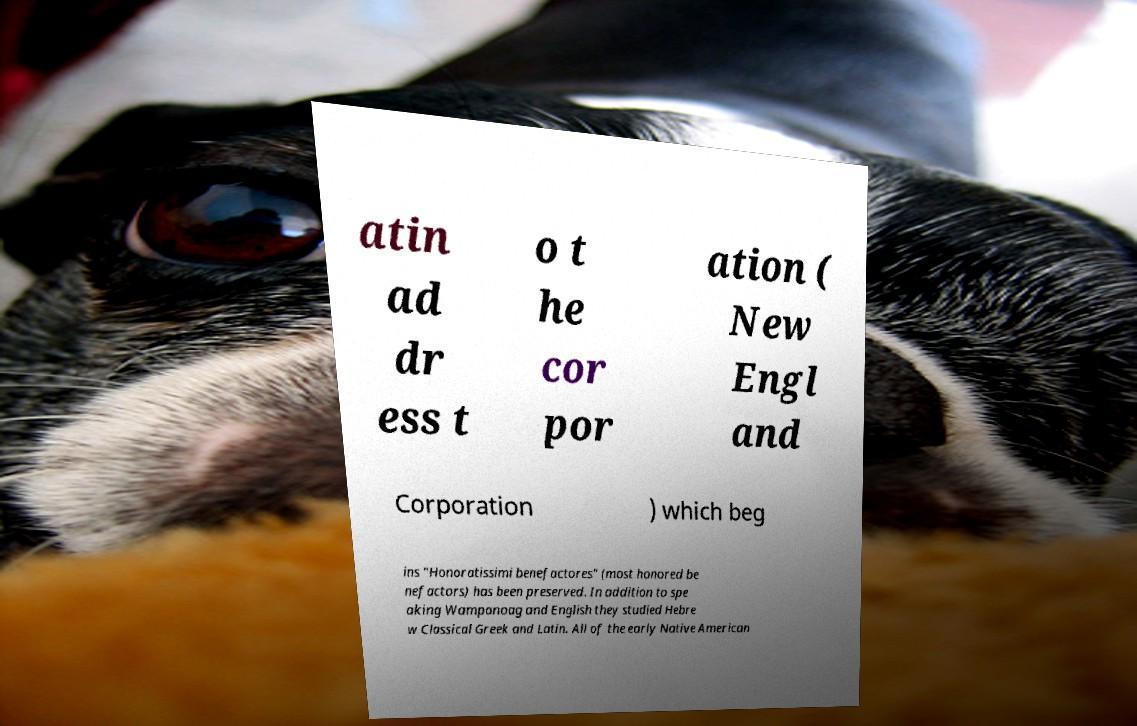What messages or text are displayed in this image? I need them in a readable, typed format. atin ad dr ess t o t he cor por ation ( New Engl and Corporation ) which beg ins "Honoratissimi benefactores" (most honored be nefactors) has been preserved. In addition to spe aking Wampanoag and English they studied Hebre w Classical Greek and Latin. All of the early Native American 